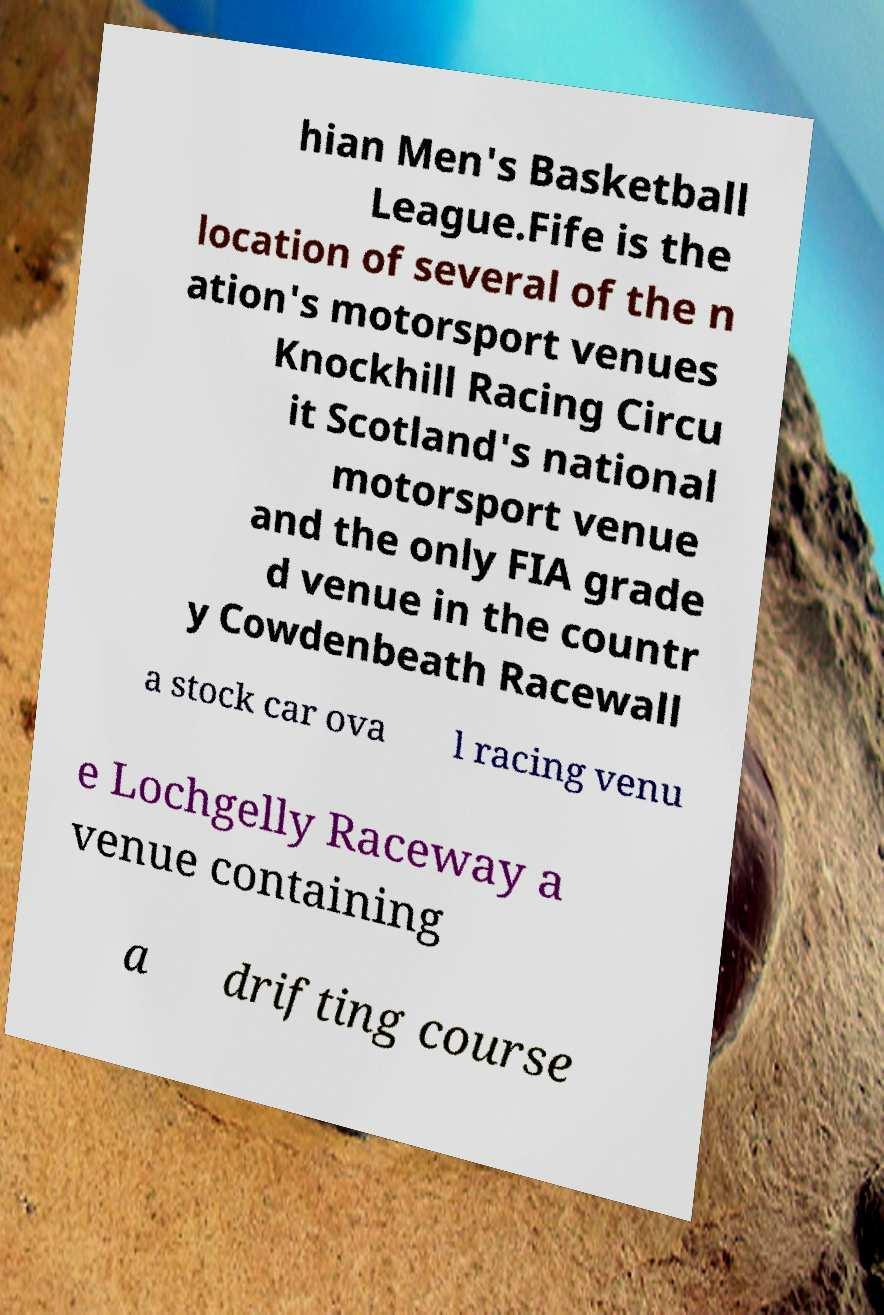There's text embedded in this image that I need extracted. Can you transcribe it verbatim? hian Men's Basketball League.Fife is the location of several of the n ation's motorsport venues Knockhill Racing Circu it Scotland's national motorsport venue and the only FIA grade d venue in the countr y Cowdenbeath Racewall a stock car ova l racing venu e Lochgelly Raceway a venue containing a drifting course 